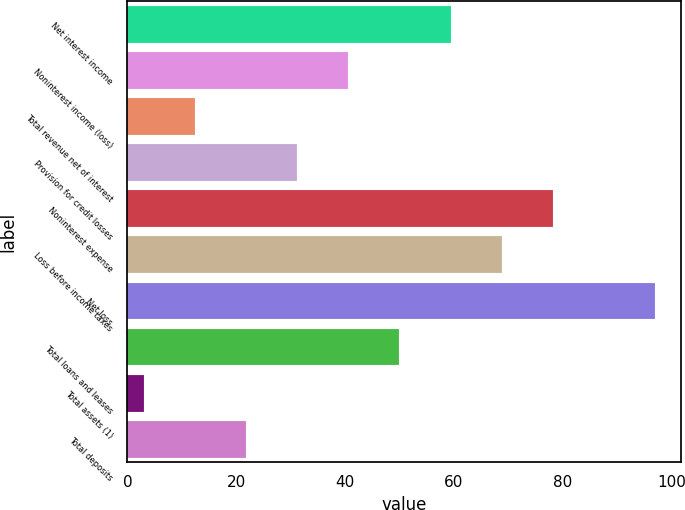Convert chart to OTSL. <chart><loc_0><loc_0><loc_500><loc_500><bar_chart><fcel>Net interest income<fcel>Noninterest income (loss)<fcel>Total revenue net of interest<fcel>Provision for credit losses<fcel>Noninterest expense<fcel>Loss before income taxes<fcel>Net loss<fcel>Total loans and leases<fcel>Total assets (1)<fcel>Total deposits<nl><fcel>59.4<fcel>40.6<fcel>12.4<fcel>31.2<fcel>78.2<fcel>68.8<fcel>97<fcel>50<fcel>3<fcel>21.8<nl></chart> 